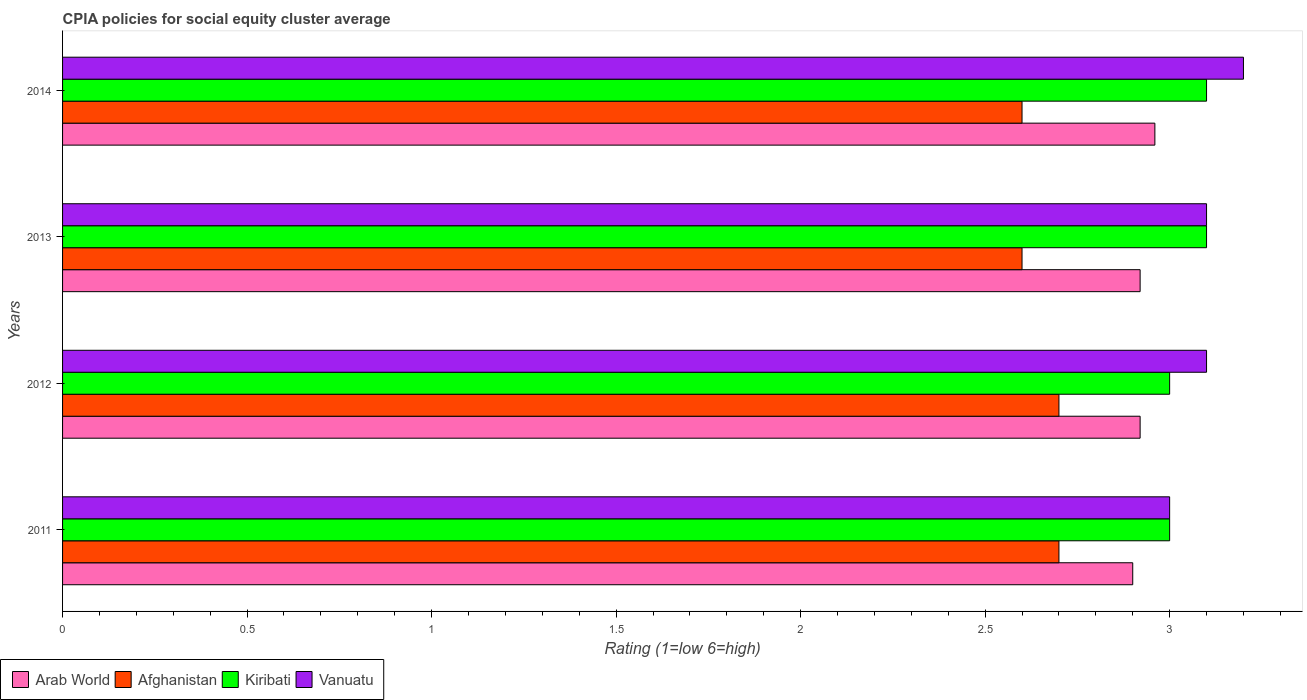How many groups of bars are there?
Keep it short and to the point. 4. Are the number of bars on each tick of the Y-axis equal?
Provide a succinct answer. Yes. In how many cases, is the number of bars for a given year not equal to the number of legend labels?
Your answer should be compact. 0. In which year was the CPIA rating in Vanuatu minimum?
Provide a short and direct response. 2011. What is the difference between the CPIA rating in Vanuatu in 2011 and that in 2013?
Make the answer very short. -0.1. What is the difference between the CPIA rating in Arab World in 2011 and the CPIA rating in Vanuatu in 2013?
Give a very brief answer. -0.2. What is the average CPIA rating in Kiribati per year?
Your answer should be very brief. 3.05. In the year 2013, what is the difference between the CPIA rating in Kiribati and CPIA rating in Afghanistan?
Your answer should be very brief. 0.5. In how many years, is the CPIA rating in Afghanistan greater than 2.1 ?
Make the answer very short. 4. What is the ratio of the CPIA rating in Afghanistan in 2012 to that in 2013?
Provide a short and direct response. 1.04. What is the difference between the highest and the lowest CPIA rating in Kiribati?
Offer a very short reply. 0.1. Is it the case that in every year, the sum of the CPIA rating in Vanuatu and CPIA rating in Arab World is greater than the sum of CPIA rating in Kiribati and CPIA rating in Afghanistan?
Give a very brief answer. Yes. What does the 3rd bar from the top in 2012 represents?
Make the answer very short. Afghanistan. What does the 2nd bar from the bottom in 2012 represents?
Keep it short and to the point. Afghanistan. Where does the legend appear in the graph?
Your response must be concise. Bottom left. What is the title of the graph?
Offer a terse response. CPIA policies for social equity cluster average. Does "Venezuela" appear as one of the legend labels in the graph?
Provide a succinct answer. No. What is the label or title of the X-axis?
Your answer should be compact. Rating (1=low 6=high). What is the Rating (1=low 6=high) of Arab World in 2011?
Offer a terse response. 2.9. What is the Rating (1=low 6=high) of Afghanistan in 2011?
Give a very brief answer. 2.7. What is the Rating (1=low 6=high) of Arab World in 2012?
Ensure brevity in your answer.  2.92. What is the Rating (1=low 6=high) of Kiribati in 2012?
Ensure brevity in your answer.  3. What is the Rating (1=low 6=high) of Vanuatu in 2012?
Your response must be concise. 3.1. What is the Rating (1=low 6=high) of Arab World in 2013?
Give a very brief answer. 2.92. What is the Rating (1=low 6=high) in Arab World in 2014?
Provide a succinct answer. 2.96. What is the Rating (1=low 6=high) in Afghanistan in 2014?
Ensure brevity in your answer.  2.6. What is the Rating (1=low 6=high) of Kiribati in 2014?
Make the answer very short. 3.1. Across all years, what is the maximum Rating (1=low 6=high) in Arab World?
Give a very brief answer. 2.96. Across all years, what is the maximum Rating (1=low 6=high) in Afghanistan?
Your answer should be very brief. 2.7. Across all years, what is the maximum Rating (1=low 6=high) of Kiribati?
Ensure brevity in your answer.  3.1. Across all years, what is the minimum Rating (1=low 6=high) in Arab World?
Your response must be concise. 2.9. Across all years, what is the minimum Rating (1=low 6=high) of Kiribati?
Give a very brief answer. 3. Across all years, what is the minimum Rating (1=low 6=high) of Vanuatu?
Your answer should be compact. 3. What is the total Rating (1=low 6=high) in Arab World in the graph?
Keep it short and to the point. 11.7. What is the difference between the Rating (1=low 6=high) of Arab World in 2011 and that in 2012?
Keep it short and to the point. -0.02. What is the difference between the Rating (1=low 6=high) in Afghanistan in 2011 and that in 2012?
Offer a terse response. 0. What is the difference between the Rating (1=low 6=high) of Vanuatu in 2011 and that in 2012?
Make the answer very short. -0.1. What is the difference between the Rating (1=low 6=high) in Arab World in 2011 and that in 2013?
Make the answer very short. -0.02. What is the difference between the Rating (1=low 6=high) of Afghanistan in 2011 and that in 2013?
Offer a terse response. 0.1. What is the difference between the Rating (1=low 6=high) of Vanuatu in 2011 and that in 2013?
Your answer should be compact. -0.1. What is the difference between the Rating (1=low 6=high) in Arab World in 2011 and that in 2014?
Provide a succinct answer. -0.06. What is the difference between the Rating (1=low 6=high) in Arab World in 2012 and that in 2013?
Your answer should be compact. 0. What is the difference between the Rating (1=low 6=high) in Kiribati in 2012 and that in 2013?
Make the answer very short. -0.1. What is the difference between the Rating (1=low 6=high) of Arab World in 2012 and that in 2014?
Provide a succinct answer. -0.04. What is the difference between the Rating (1=low 6=high) in Vanuatu in 2012 and that in 2014?
Give a very brief answer. -0.1. What is the difference between the Rating (1=low 6=high) of Arab World in 2013 and that in 2014?
Provide a succinct answer. -0.04. What is the difference between the Rating (1=low 6=high) of Vanuatu in 2013 and that in 2014?
Your answer should be compact. -0.1. What is the difference between the Rating (1=low 6=high) of Arab World in 2011 and the Rating (1=low 6=high) of Afghanistan in 2013?
Your answer should be compact. 0.3. What is the difference between the Rating (1=low 6=high) of Arab World in 2011 and the Rating (1=low 6=high) of Vanuatu in 2013?
Make the answer very short. -0.2. What is the difference between the Rating (1=low 6=high) in Afghanistan in 2011 and the Rating (1=low 6=high) in Kiribati in 2013?
Give a very brief answer. -0.4. What is the difference between the Rating (1=low 6=high) in Kiribati in 2011 and the Rating (1=low 6=high) in Vanuatu in 2014?
Your response must be concise. -0.2. What is the difference between the Rating (1=low 6=high) of Arab World in 2012 and the Rating (1=low 6=high) of Afghanistan in 2013?
Provide a short and direct response. 0.32. What is the difference between the Rating (1=low 6=high) of Arab World in 2012 and the Rating (1=low 6=high) of Kiribati in 2013?
Your answer should be compact. -0.18. What is the difference between the Rating (1=low 6=high) in Arab World in 2012 and the Rating (1=low 6=high) in Vanuatu in 2013?
Offer a terse response. -0.18. What is the difference between the Rating (1=low 6=high) of Kiribati in 2012 and the Rating (1=low 6=high) of Vanuatu in 2013?
Provide a short and direct response. -0.1. What is the difference between the Rating (1=low 6=high) of Arab World in 2012 and the Rating (1=low 6=high) of Afghanistan in 2014?
Your response must be concise. 0.32. What is the difference between the Rating (1=low 6=high) of Arab World in 2012 and the Rating (1=low 6=high) of Kiribati in 2014?
Keep it short and to the point. -0.18. What is the difference between the Rating (1=low 6=high) of Arab World in 2012 and the Rating (1=low 6=high) of Vanuatu in 2014?
Provide a succinct answer. -0.28. What is the difference between the Rating (1=low 6=high) of Afghanistan in 2012 and the Rating (1=low 6=high) of Vanuatu in 2014?
Keep it short and to the point. -0.5. What is the difference between the Rating (1=low 6=high) of Arab World in 2013 and the Rating (1=low 6=high) of Afghanistan in 2014?
Provide a succinct answer. 0.32. What is the difference between the Rating (1=low 6=high) in Arab World in 2013 and the Rating (1=low 6=high) in Kiribati in 2014?
Keep it short and to the point. -0.18. What is the difference between the Rating (1=low 6=high) in Arab World in 2013 and the Rating (1=low 6=high) in Vanuatu in 2014?
Provide a short and direct response. -0.28. What is the difference between the Rating (1=low 6=high) of Afghanistan in 2013 and the Rating (1=low 6=high) of Kiribati in 2014?
Your answer should be very brief. -0.5. What is the difference between the Rating (1=low 6=high) in Kiribati in 2013 and the Rating (1=low 6=high) in Vanuatu in 2014?
Give a very brief answer. -0.1. What is the average Rating (1=low 6=high) of Arab World per year?
Give a very brief answer. 2.92. What is the average Rating (1=low 6=high) of Afghanistan per year?
Ensure brevity in your answer.  2.65. What is the average Rating (1=low 6=high) in Kiribati per year?
Provide a short and direct response. 3.05. What is the average Rating (1=low 6=high) in Vanuatu per year?
Offer a very short reply. 3.1. In the year 2011, what is the difference between the Rating (1=low 6=high) in Arab World and Rating (1=low 6=high) in Kiribati?
Keep it short and to the point. -0.1. In the year 2011, what is the difference between the Rating (1=low 6=high) in Kiribati and Rating (1=low 6=high) in Vanuatu?
Provide a succinct answer. 0. In the year 2012, what is the difference between the Rating (1=low 6=high) of Arab World and Rating (1=low 6=high) of Afghanistan?
Ensure brevity in your answer.  0.22. In the year 2012, what is the difference between the Rating (1=low 6=high) of Arab World and Rating (1=low 6=high) of Kiribati?
Your response must be concise. -0.08. In the year 2012, what is the difference between the Rating (1=low 6=high) in Arab World and Rating (1=low 6=high) in Vanuatu?
Keep it short and to the point. -0.18. In the year 2012, what is the difference between the Rating (1=low 6=high) in Afghanistan and Rating (1=low 6=high) in Kiribati?
Offer a very short reply. -0.3. In the year 2012, what is the difference between the Rating (1=low 6=high) in Afghanistan and Rating (1=low 6=high) in Vanuatu?
Give a very brief answer. -0.4. In the year 2013, what is the difference between the Rating (1=low 6=high) in Arab World and Rating (1=low 6=high) in Afghanistan?
Offer a terse response. 0.32. In the year 2013, what is the difference between the Rating (1=low 6=high) of Arab World and Rating (1=low 6=high) of Kiribati?
Offer a very short reply. -0.18. In the year 2013, what is the difference between the Rating (1=low 6=high) in Arab World and Rating (1=low 6=high) in Vanuatu?
Give a very brief answer. -0.18. In the year 2013, what is the difference between the Rating (1=low 6=high) in Afghanistan and Rating (1=low 6=high) in Kiribati?
Make the answer very short. -0.5. In the year 2013, what is the difference between the Rating (1=low 6=high) of Kiribati and Rating (1=low 6=high) of Vanuatu?
Provide a short and direct response. 0. In the year 2014, what is the difference between the Rating (1=low 6=high) in Arab World and Rating (1=low 6=high) in Afghanistan?
Offer a terse response. 0.36. In the year 2014, what is the difference between the Rating (1=low 6=high) of Arab World and Rating (1=low 6=high) of Kiribati?
Offer a very short reply. -0.14. In the year 2014, what is the difference between the Rating (1=low 6=high) in Arab World and Rating (1=low 6=high) in Vanuatu?
Give a very brief answer. -0.24. In the year 2014, what is the difference between the Rating (1=low 6=high) of Afghanistan and Rating (1=low 6=high) of Kiribati?
Give a very brief answer. -0.5. In the year 2014, what is the difference between the Rating (1=low 6=high) in Afghanistan and Rating (1=low 6=high) in Vanuatu?
Keep it short and to the point. -0.6. What is the ratio of the Rating (1=low 6=high) in Arab World in 2011 to that in 2012?
Provide a succinct answer. 0.99. What is the ratio of the Rating (1=low 6=high) in Afghanistan in 2011 to that in 2012?
Provide a short and direct response. 1. What is the ratio of the Rating (1=low 6=high) of Arab World in 2011 to that in 2013?
Make the answer very short. 0.99. What is the ratio of the Rating (1=low 6=high) in Afghanistan in 2011 to that in 2013?
Ensure brevity in your answer.  1.04. What is the ratio of the Rating (1=low 6=high) in Arab World in 2011 to that in 2014?
Offer a very short reply. 0.98. What is the ratio of the Rating (1=low 6=high) of Kiribati in 2011 to that in 2014?
Ensure brevity in your answer.  0.97. What is the ratio of the Rating (1=low 6=high) in Vanuatu in 2011 to that in 2014?
Offer a very short reply. 0.94. What is the ratio of the Rating (1=low 6=high) in Arab World in 2012 to that in 2013?
Your response must be concise. 1. What is the ratio of the Rating (1=low 6=high) of Afghanistan in 2012 to that in 2013?
Ensure brevity in your answer.  1.04. What is the ratio of the Rating (1=low 6=high) of Kiribati in 2012 to that in 2013?
Provide a short and direct response. 0.97. What is the ratio of the Rating (1=low 6=high) in Arab World in 2012 to that in 2014?
Provide a succinct answer. 0.99. What is the ratio of the Rating (1=low 6=high) in Vanuatu in 2012 to that in 2014?
Offer a terse response. 0.97. What is the ratio of the Rating (1=low 6=high) of Arab World in 2013 to that in 2014?
Offer a very short reply. 0.99. What is the ratio of the Rating (1=low 6=high) in Kiribati in 2013 to that in 2014?
Make the answer very short. 1. What is the ratio of the Rating (1=low 6=high) in Vanuatu in 2013 to that in 2014?
Offer a very short reply. 0.97. What is the difference between the highest and the second highest Rating (1=low 6=high) of Arab World?
Keep it short and to the point. 0.04. What is the difference between the highest and the second highest Rating (1=low 6=high) of Kiribati?
Your answer should be very brief. 0. What is the difference between the highest and the lowest Rating (1=low 6=high) of Arab World?
Make the answer very short. 0.06. What is the difference between the highest and the lowest Rating (1=low 6=high) in Afghanistan?
Your response must be concise. 0.1. 